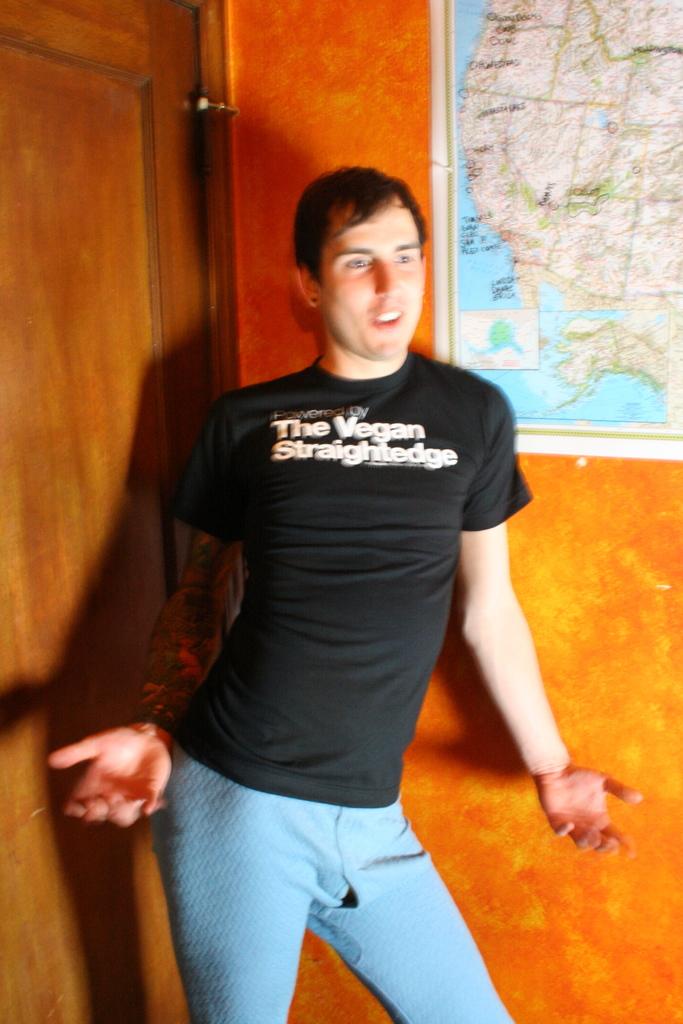According to the man's shirt, what diet does he follow?
Provide a succinct answer. Vegan. 